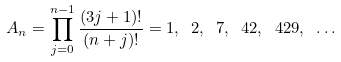Convert formula to latex. <formula><loc_0><loc_0><loc_500><loc_500>A _ { n } = \prod _ { j = 0 } ^ { n - 1 } \frac { ( 3 j + 1 ) ! } { ( n + j ) ! } = 1 , \ 2 , \ 7 , \ 4 2 , \ 4 2 9 , \ \dots</formula> 